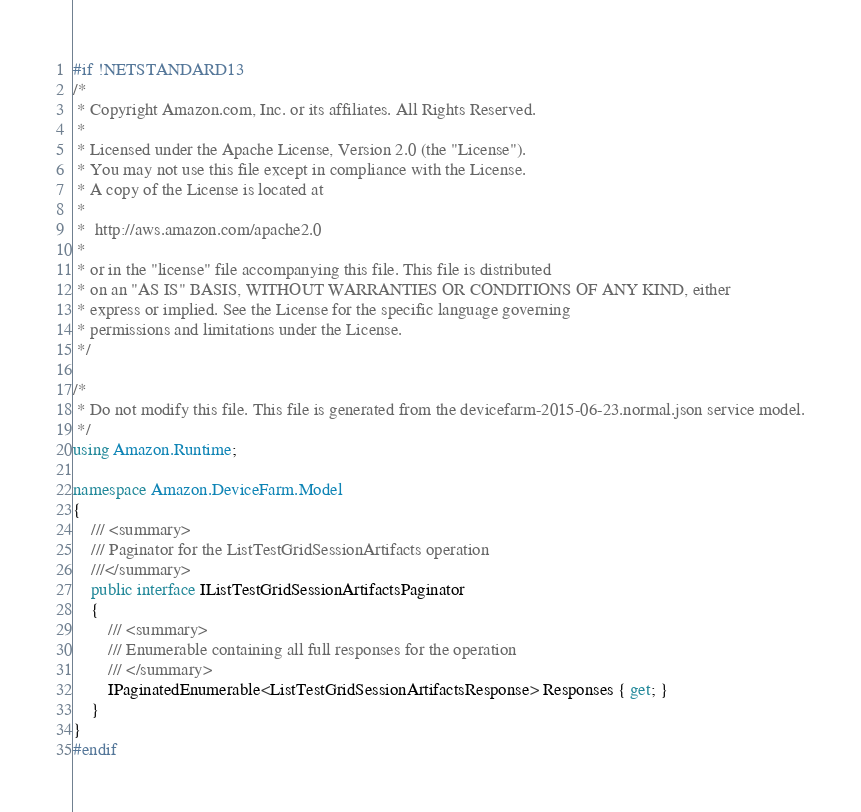<code> <loc_0><loc_0><loc_500><loc_500><_C#_>#if !NETSTANDARD13
/*
 * Copyright Amazon.com, Inc. or its affiliates. All Rights Reserved.
 * 
 * Licensed under the Apache License, Version 2.0 (the "License").
 * You may not use this file except in compliance with the License.
 * A copy of the License is located at
 * 
 *  http://aws.amazon.com/apache2.0
 * 
 * or in the "license" file accompanying this file. This file is distributed
 * on an "AS IS" BASIS, WITHOUT WARRANTIES OR CONDITIONS OF ANY KIND, either
 * express or implied. See the License for the specific language governing
 * permissions and limitations under the License.
 */

/*
 * Do not modify this file. This file is generated from the devicefarm-2015-06-23.normal.json service model.
 */
using Amazon.Runtime;

namespace Amazon.DeviceFarm.Model
{
    /// <summary>
    /// Paginator for the ListTestGridSessionArtifacts operation
    ///</summary>
    public interface IListTestGridSessionArtifactsPaginator
    {
        /// <summary>
        /// Enumerable containing all full responses for the operation
        /// </summary>
        IPaginatedEnumerable<ListTestGridSessionArtifactsResponse> Responses { get; }
    }
}
#endif</code> 